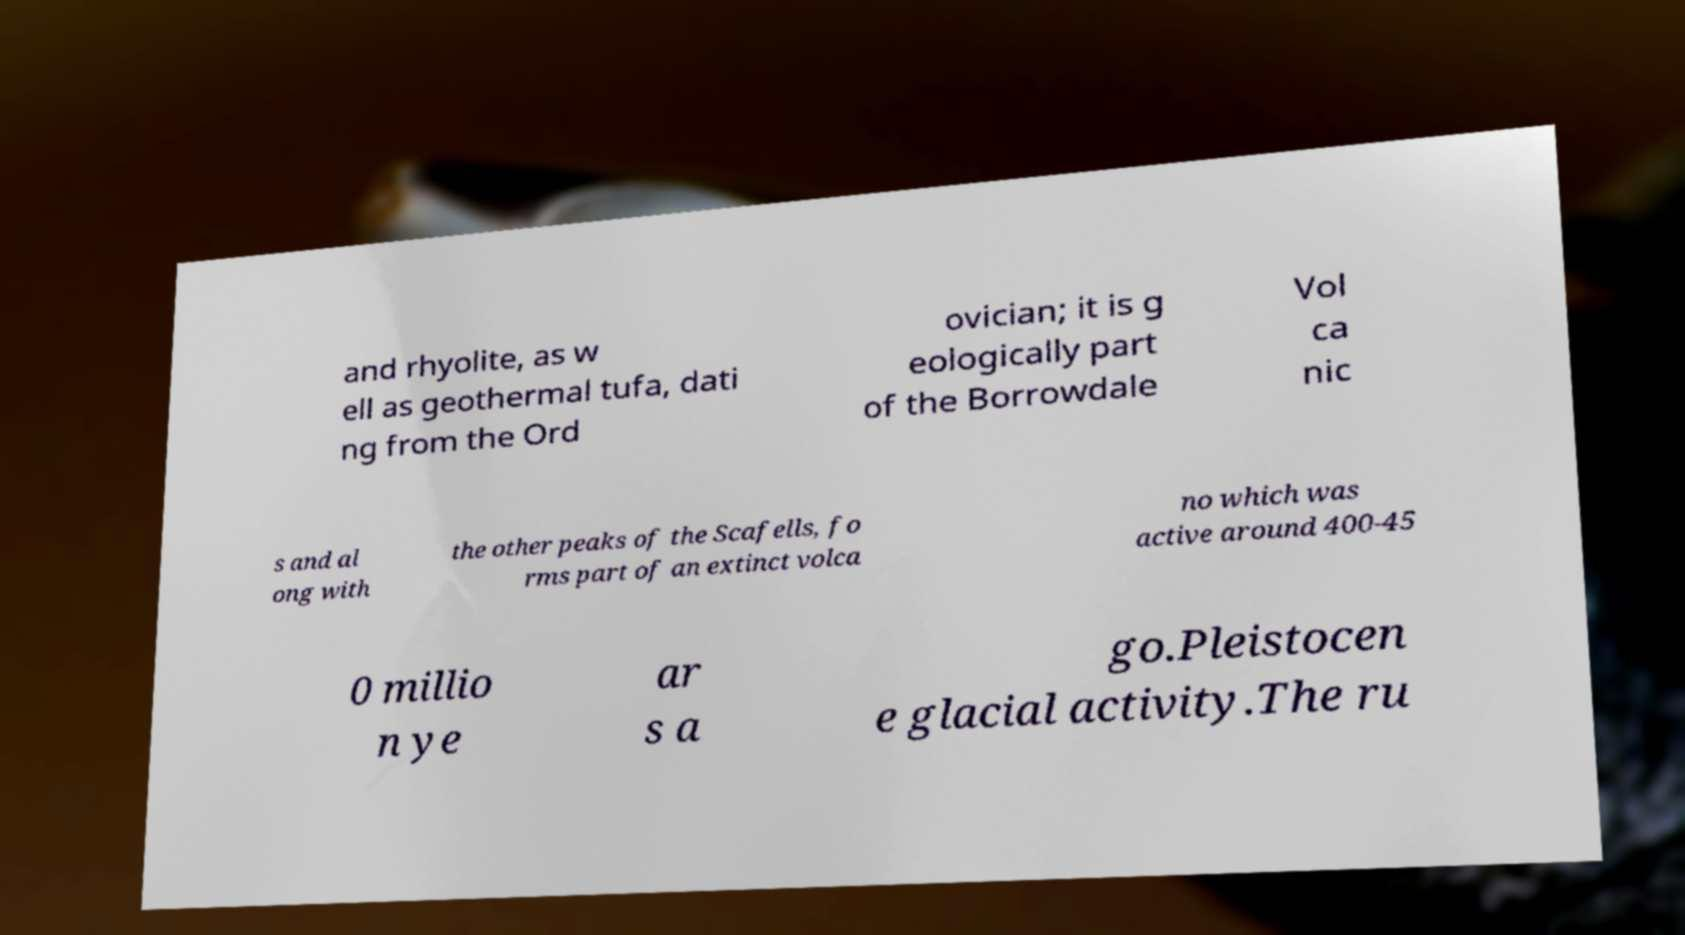Could you assist in decoding the text presented in this image and type it out clearly? and rhyolite, as w ell as geothermal tufa, dati ng from the Ord ovician; it is g eologically part of the Borrowdale Vol ca nic s and al ong with the other peaks of the Scafells, fo rms part of an extinct volca no which was active around 400-45 0 millio n ye ar s a go.Pleistocen e glacial activity.The ru 